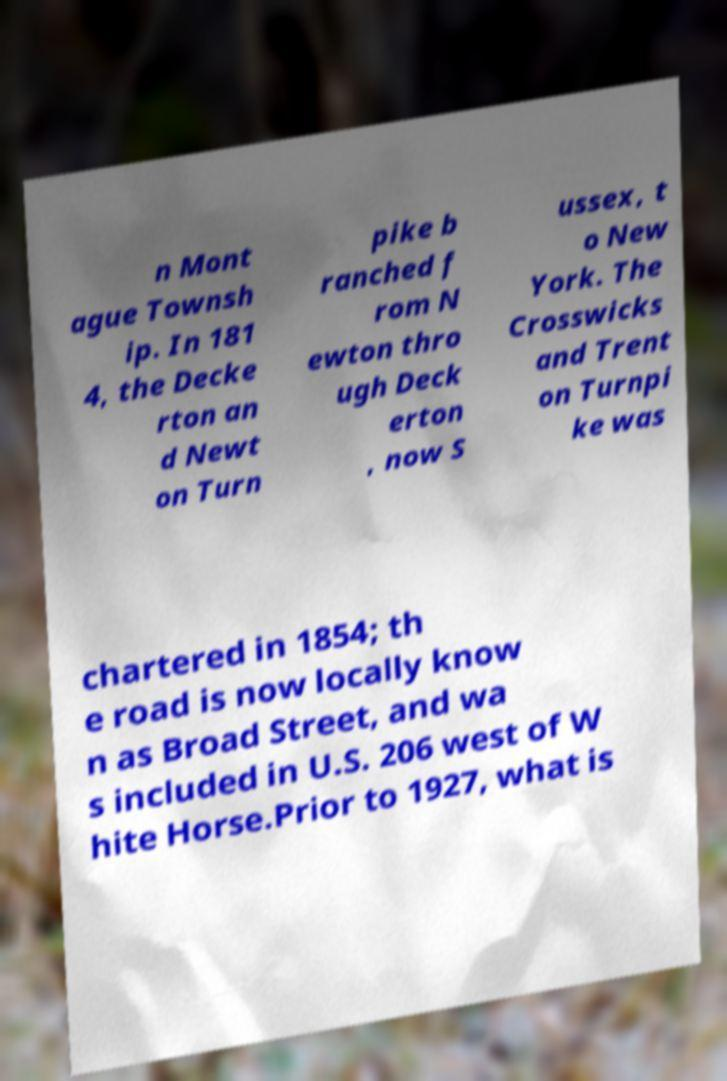Please identify and transcribe the text found in this image. n Mont ague Townsh ip. In 181 4, the Decke rton an d Newt on Turn pike b ranched f rom N ewton thro ugh Deck erton , now S ussex, t o New York. The Crosswicks and Trent on Turnpi ke was chartered in 1854; th e road is now locally know n as Broad Street, and wa s included in U.S. 206 west of W hite Horse.Prior to 1927, what is 